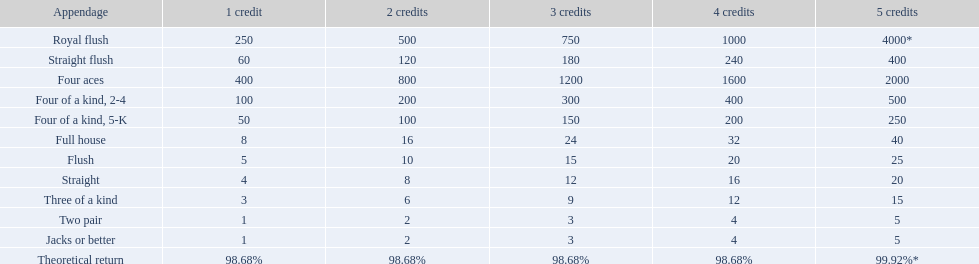What are the different hands? Royal flush, Straight flush, Four aces, Four of a kind, 2-4, Four of a kind, 5-K, Full house, Flush, Straight, Three of a kind, Two pair, Jacks or better. Which hands have a higher standing than a straight? Royal flush, Straight flush, Four aces, Four of a kind, 2-4, Four of a kind, 5-K, Full house, Flush. Of these, which hand is the next highest after a straight? Flush. 